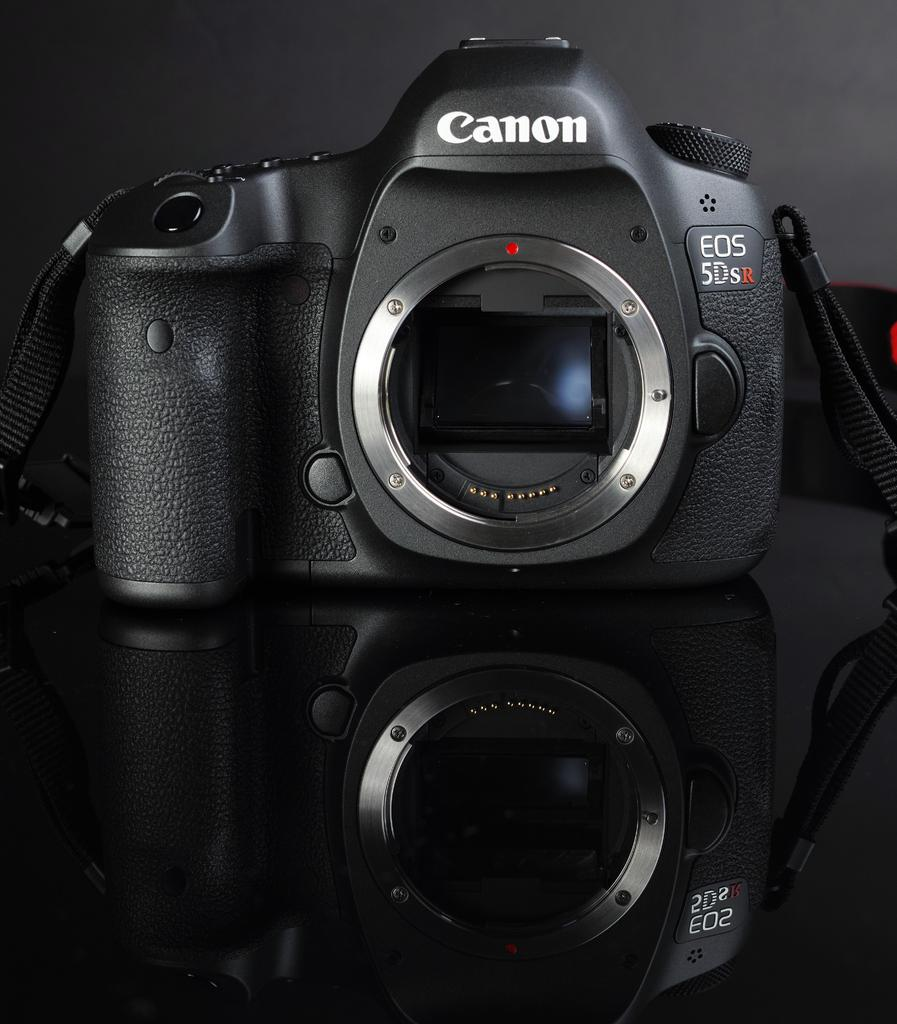<image>
Present a compact description of the photo's key features. A Black Canon Eos 5Dsr Camera sitting on a black glass table. 